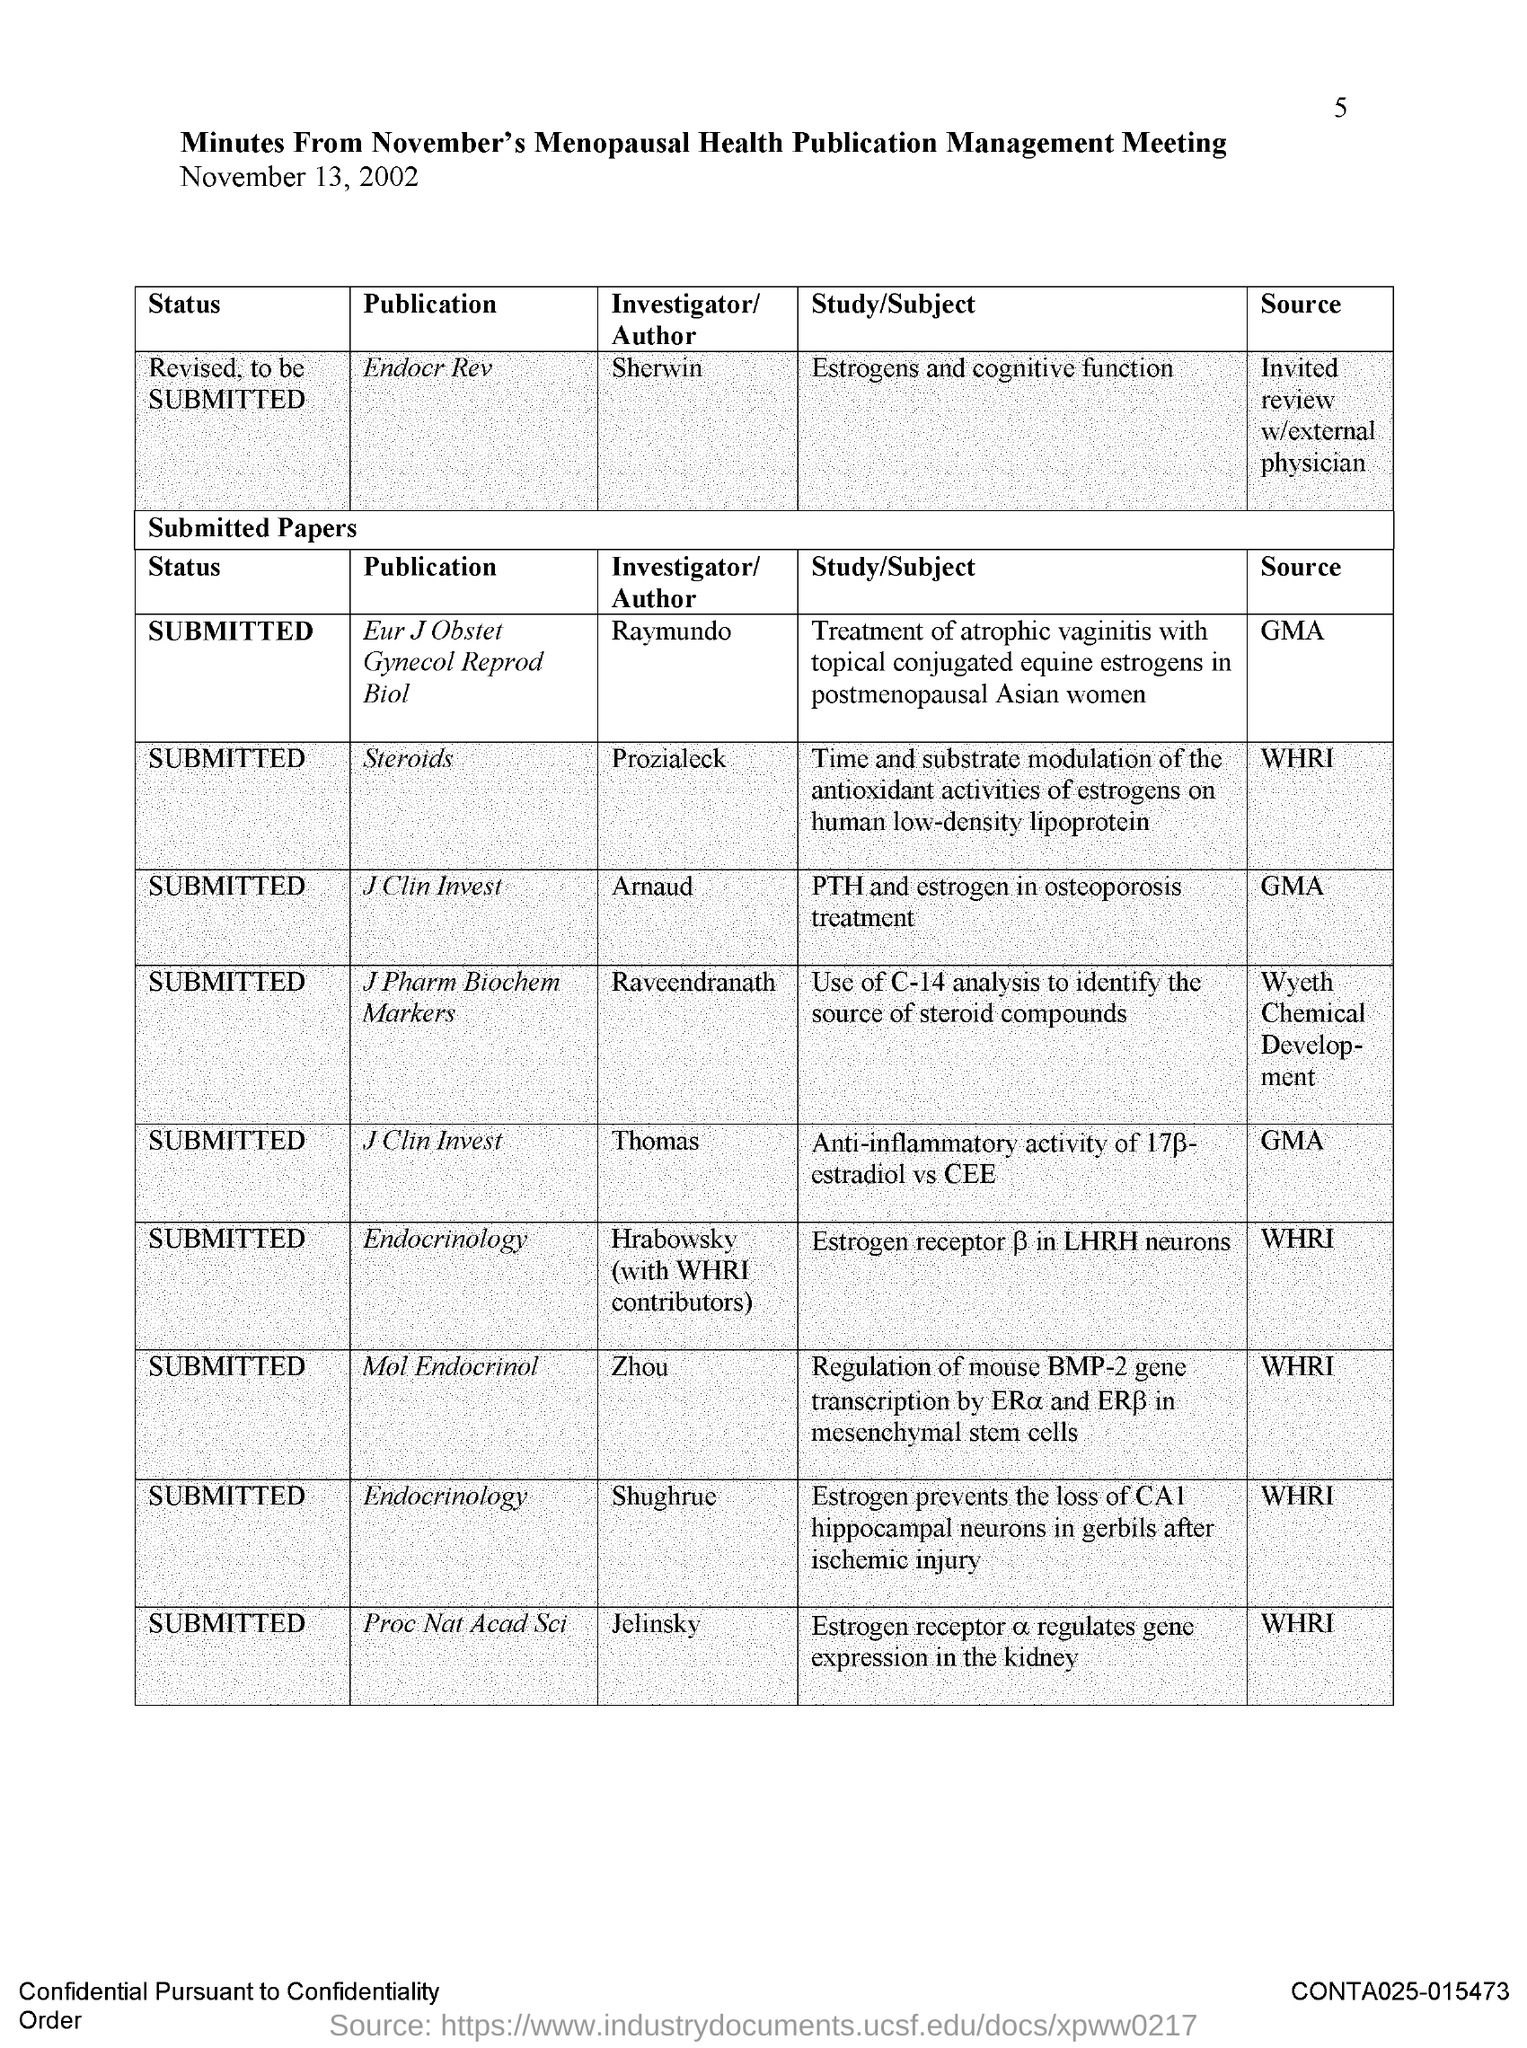Highlight a few significant elements in this photo. The page number is 5. The publication "Steroids" is currently in the submission stage. The document in question is titled 'Minutes from November's Menopausal Health Publication Management Meeting.' The publication "Steroids" was authored by Prozialeck. The author of the publication "Mol Endocrinol" is Zhou. 